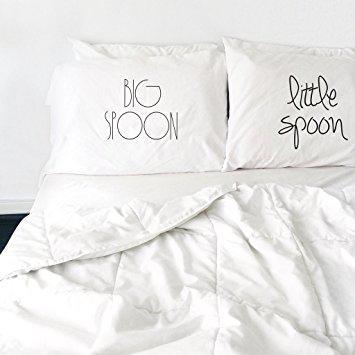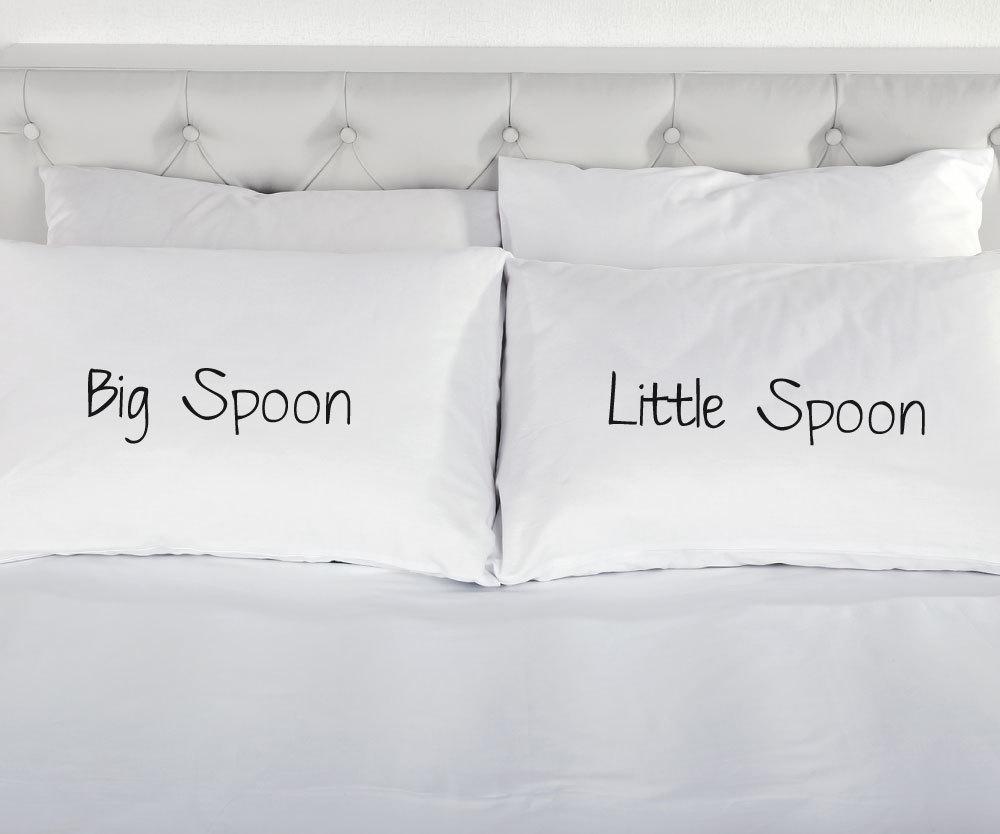The first image is the image on the left, the second image is the image on the right. For the images displayed, is the sentence "there are humans sleeping" factually correct? Answer yes or no. No. The first image is the image on the left, the second image is the image on the right. Given the left and right images, does the statement "There is no less than one sleeping woman visible" hold true? Answer yes or no. No. 